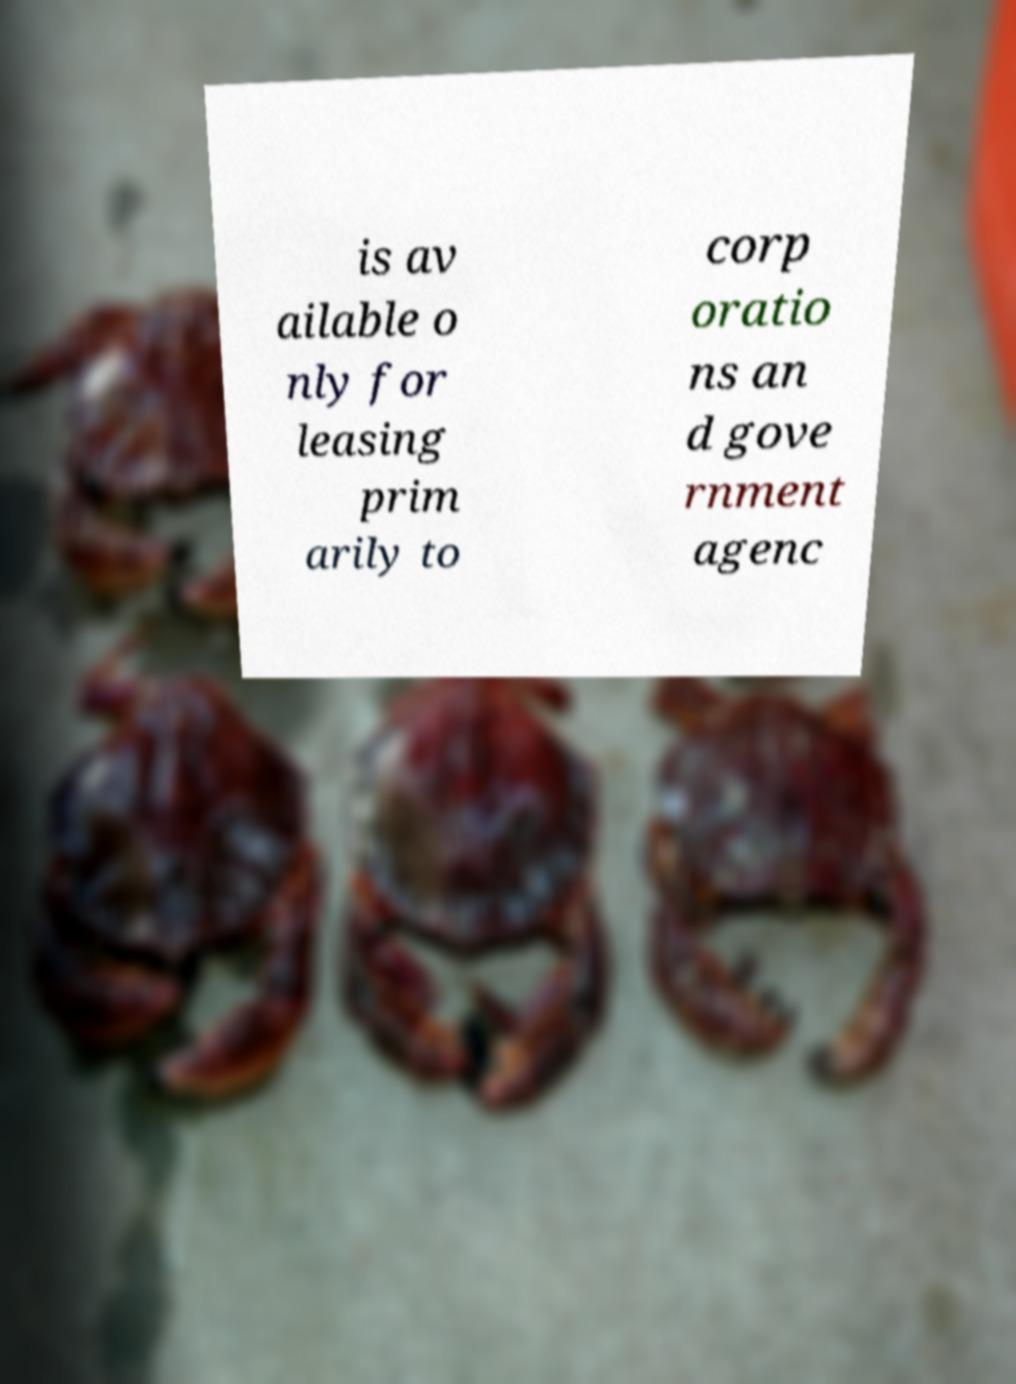Could you assist in decoding the text presented in this image and type it out clearly? is av ailable o nly for leasing prim arily to corp oratio ns an d gove rnment agenc 